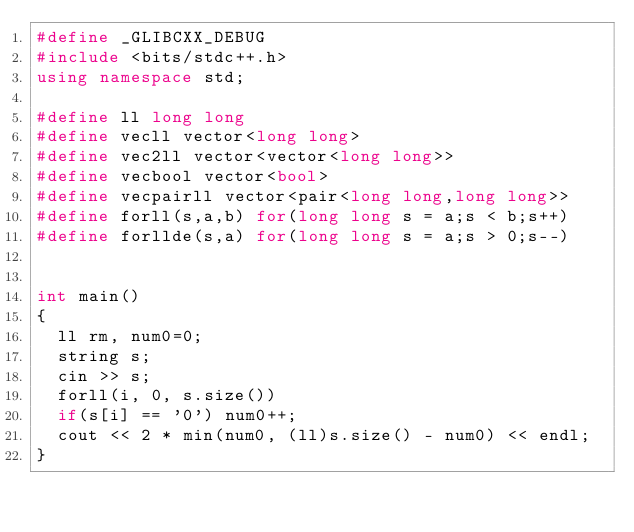<code> <loc_0><loc_0><loc_500><loc_500><_C++_>#define _GLIBCXX_DEBUG
#include <bits/stdc++.h>
using namespace std;

#define ll long long
#define vecll vector<long long>
#define vec2ll vector<vector<long long>>
#define vecbool vector<bool>
#define vecpairll vector<pair<long long,long long>>
#define forll(s,a,b) for(long long s = a;s < b;s++)
#define forllde(s,a) for(long long s = a;s > 0;s--)


int main()
{
  ll rm, num0=0;
  string s;
  cin >> s;
  forll(i, 0, s.size())
	if(s[i] == '0') num0++;
  cout << 2 * min(num0, (ll)s.size() - num0) << endl;
}
</code> 